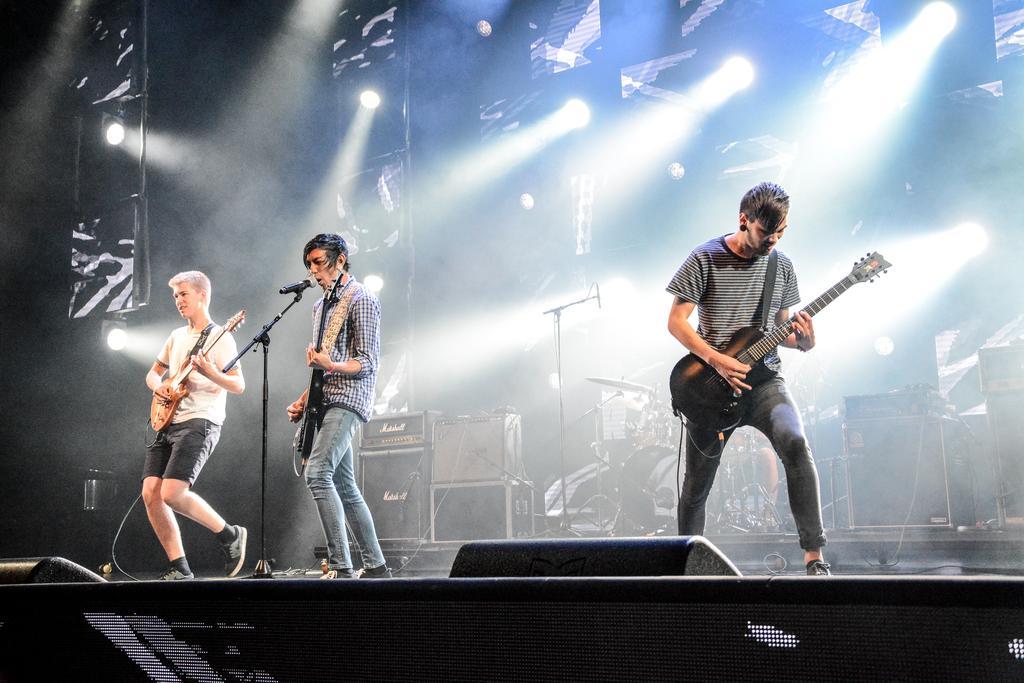In one or two sentences, can you explain what this image depicts? this picture shows three men playing guitar and a middleman singing with the help of a microphone and we see a man playing drums on the back 